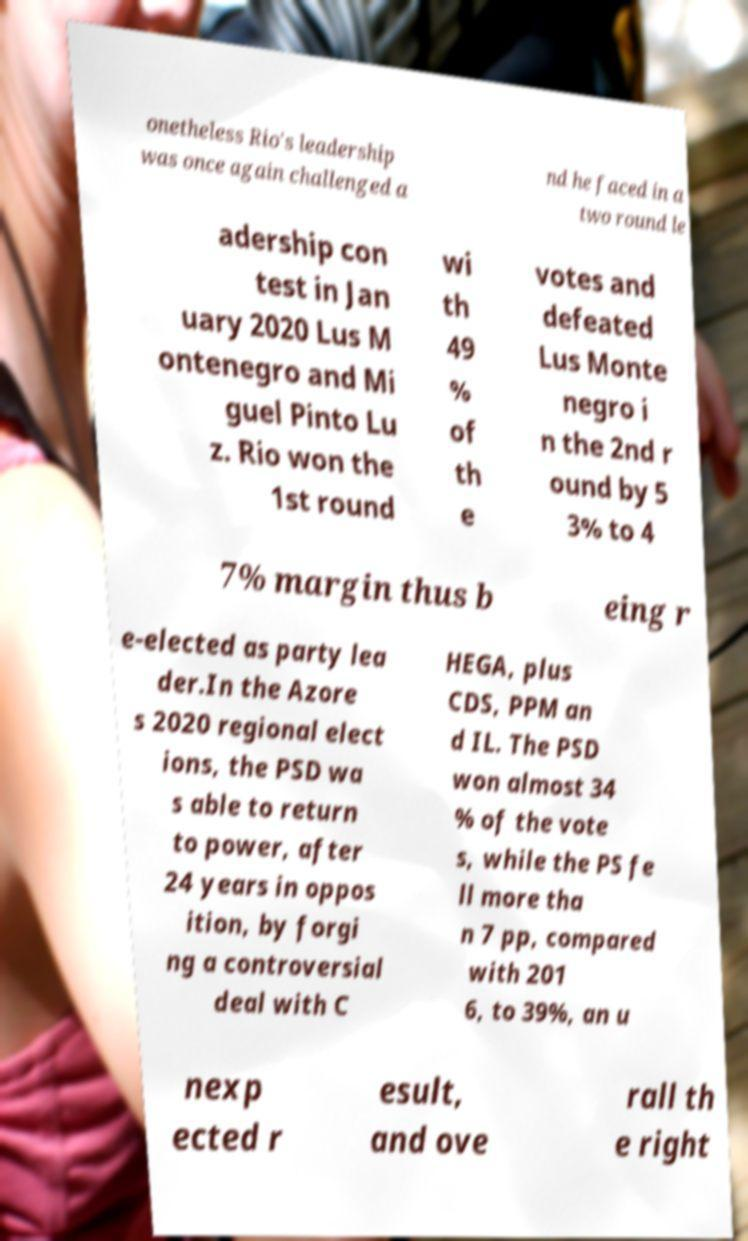Please identify and transcribe the text found in this image. onetheless Rio's leadership was once again challenged a nd he faced in a two round le adership con test in Jan uary 2020 Lus M ontenegro and Mi guel Pinto Lu z. Rio won the 1st round wi th 49 % of th e votes and defeated Lus Monte negro i n the 2nd r ound by 5 3% to 4 7% margin thus b eing r e-elected as party lea der.In the Azore s 2020 regional elect ions, the PSD wa s able to return to power, after 24 years in oppos ition, by forgi ng a controversial deal with C HEGA, plus CDS, PPM an d IL. The PSD won almost 34 % of the vote s, while the PS fe ll more tha n 7 pp, compared with 201 6, to 39%, an u nexp ected r esult, and ove rall th e right 